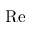<formula> <loc_0><loc_0><loc_500><loc_500>R e</formula> 